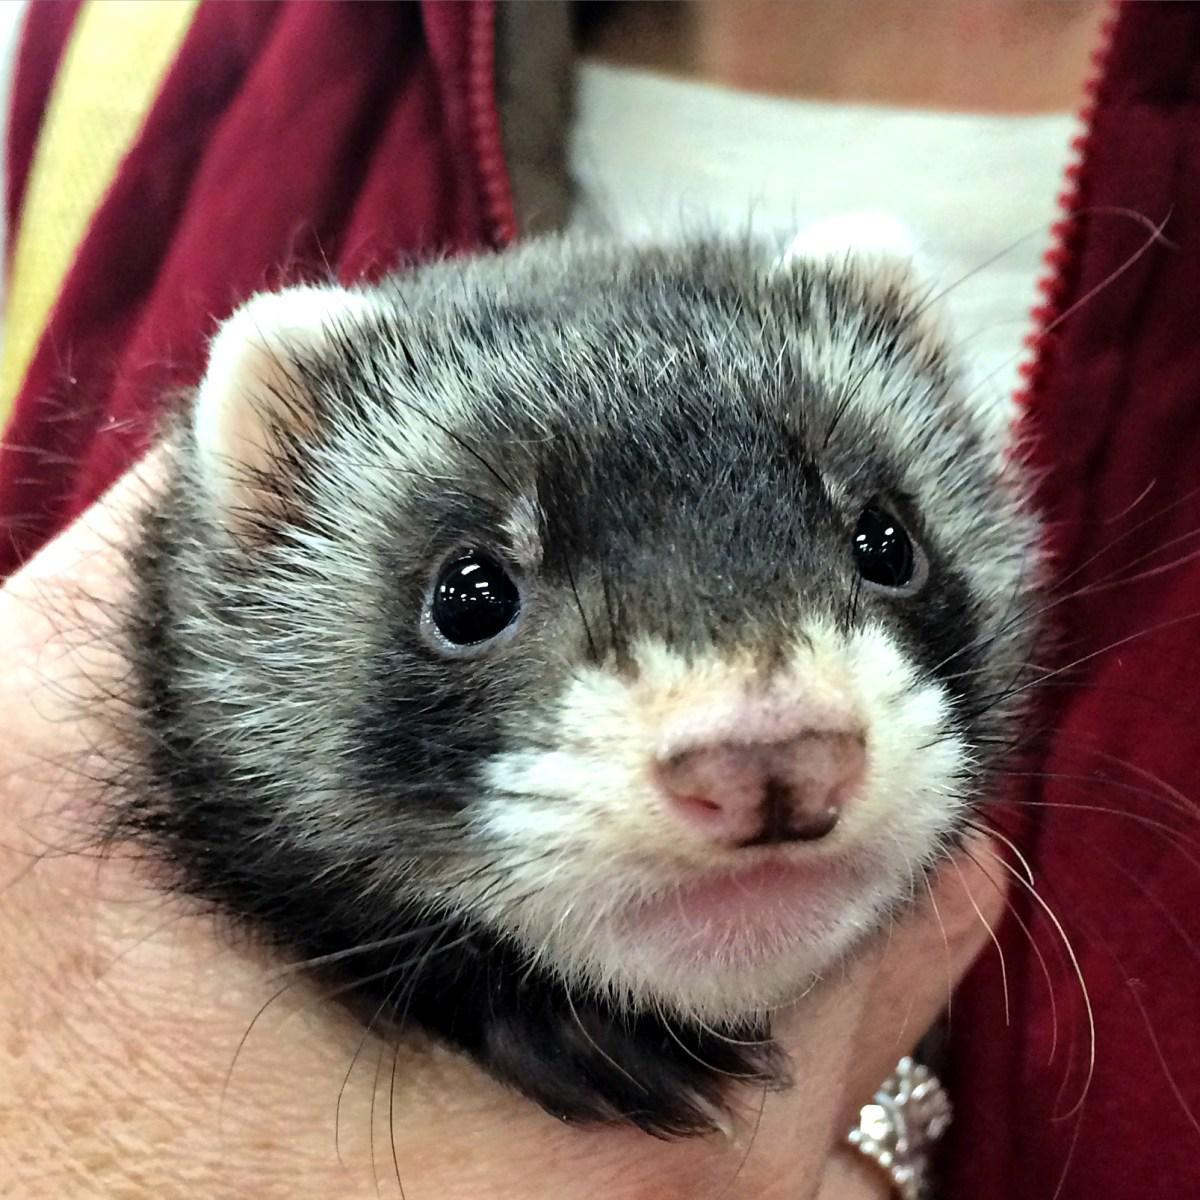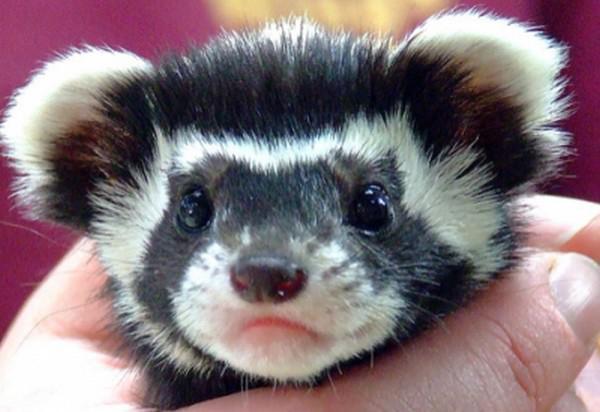The first image is the image on the left, the second image is the image on the right. Evaluate the accuracy of this statement regarding the images: "Someone is offering a ferret a piece of raw meat in at least one image.". Is it true? Answer yes or no. No. The first image is the image on the left, the second image is the image on the right. Considering the images on both sides, is "The left and right image contains the same number of ferrits with at least one person hand in one image." valid? Answer yes or no. Yes. 